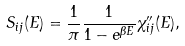<formula> <loc_0><loc_0><loc_500><loc_500>S _ { i j } ( E ) = \frac { 1 } { \pi } \frac { 1 } { 1 - e ^ { \beta E } } \chi _ { i j } ^ { \prime \prime } ( E ) ,</formula> 